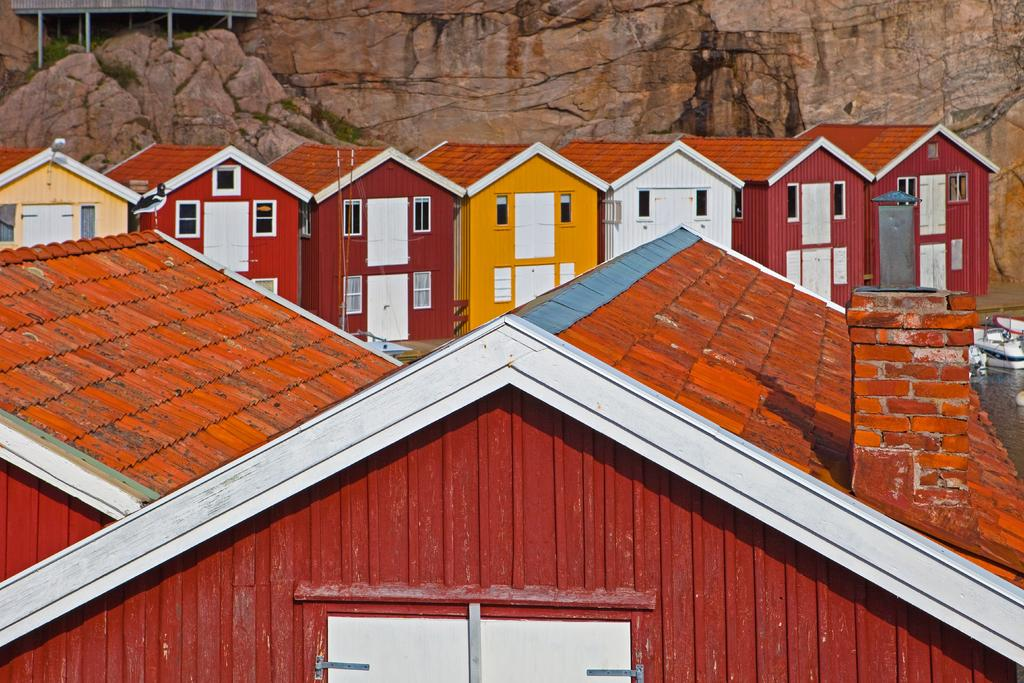What type of structures can be seen in the image? There are houses in the image. What is on the water in the image? There are boats on the water in the image. What can be seen in the background of the image? There are rocks, a shed, and plants in the background of the image. What type of button is being used to cook breakfast in the image? There is no button or cooking activity present in the image. 